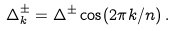<formula> <loc_0><loc_0><loc_500><loc_500>\Delta ^ { \pm } _ { k } = \Delta ^ { \pm } \cos ( 2 \pi k / n ) \, .</formula> 